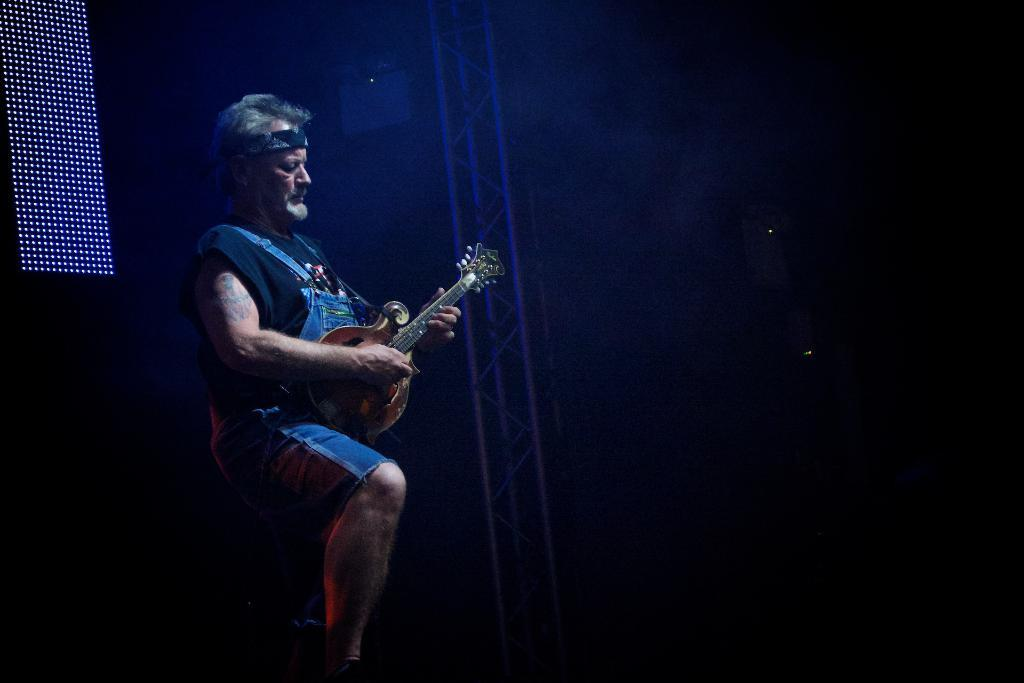What is the main subject of the image? The main subject of the image is a man. What is the man doing in the image? The man is playing a guitar in the image. What letters can be seen in the notebook that the man is writing in? There is no notebook or letters present in the image; the man is playing a guitar. 